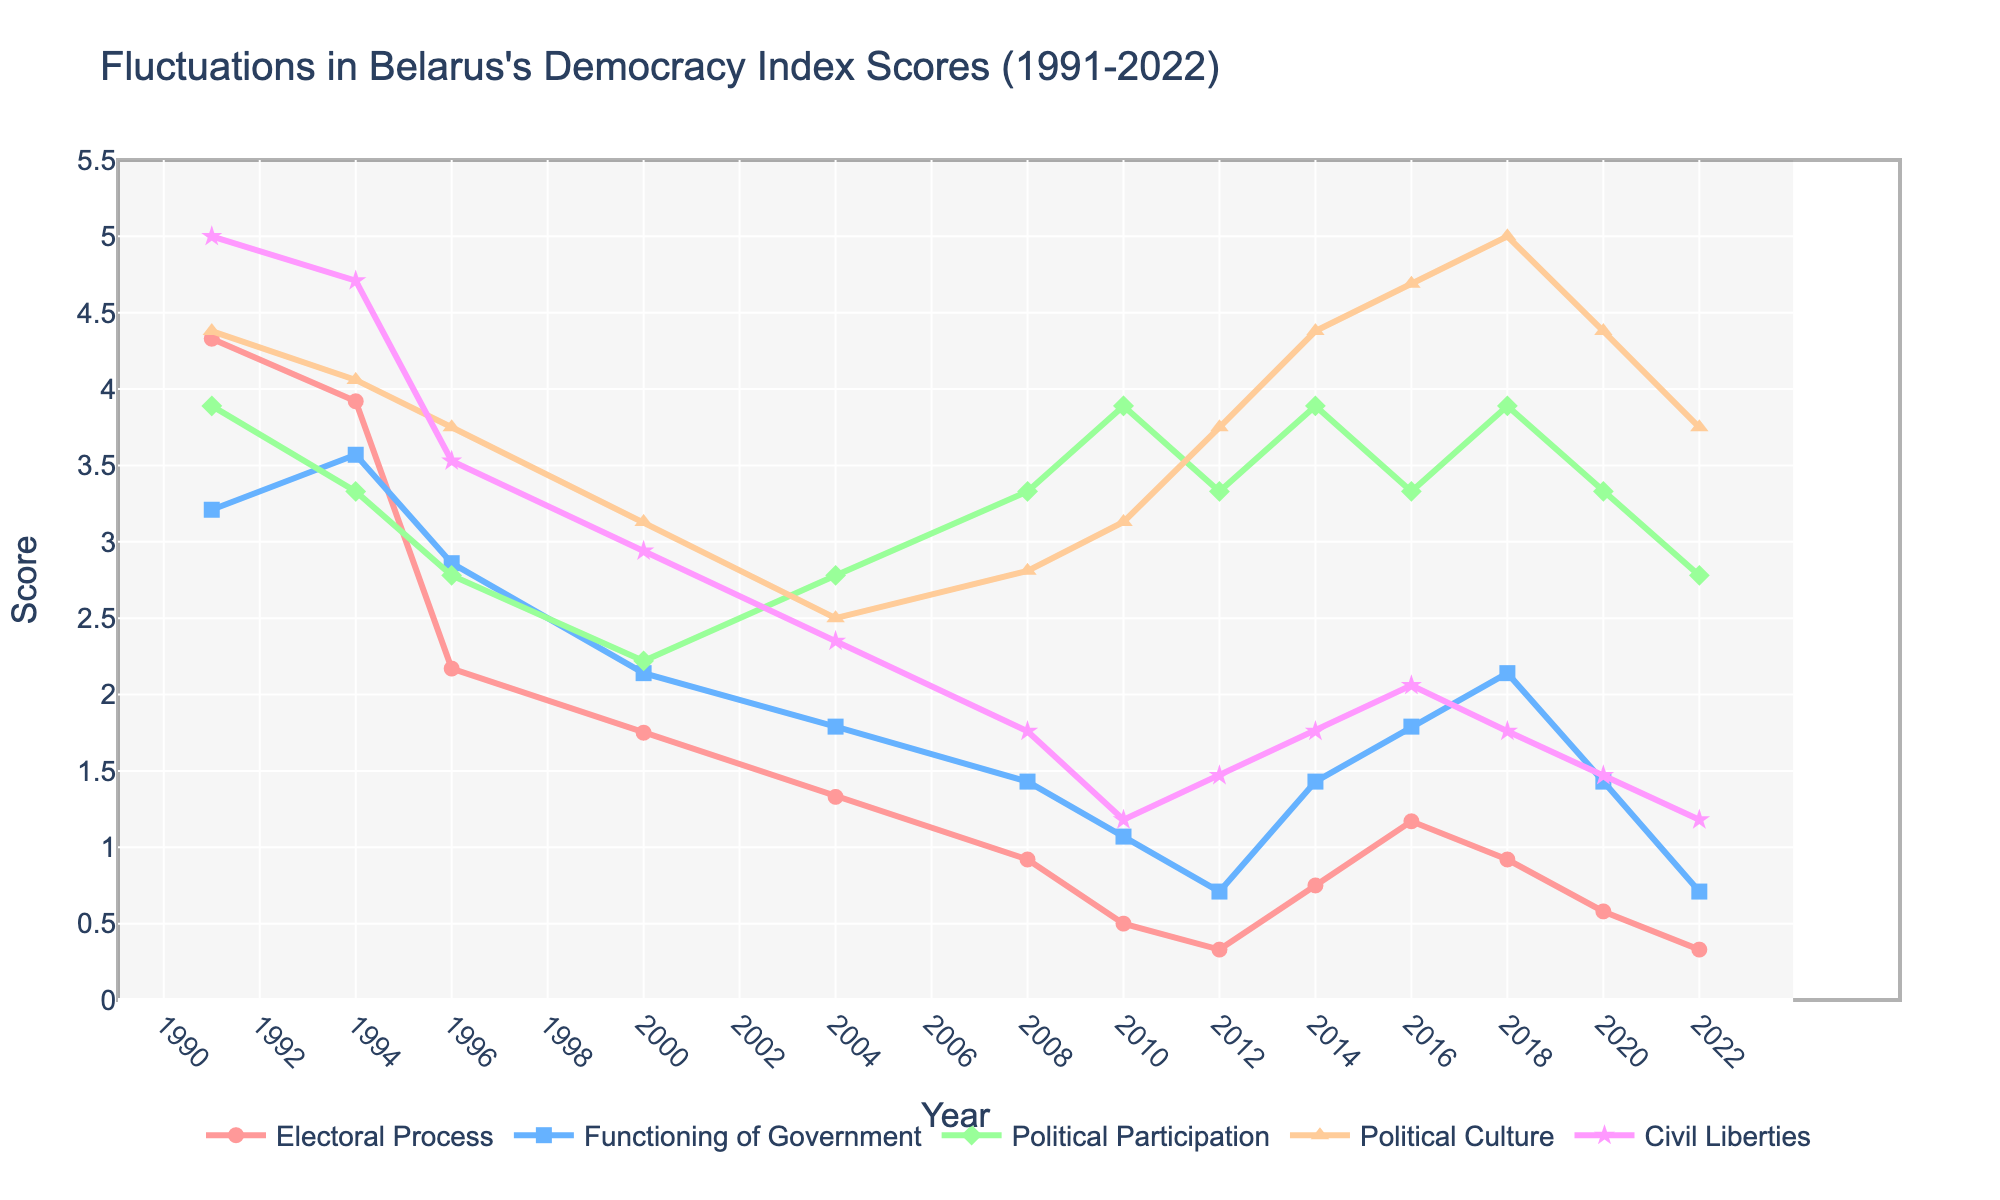What year had the highest score for Political Culture? Looking at the plot, find the highest point for the Political Culture line (triangle-up markers). The highest point is in the year 2018.
Answer: 2018 Which category showed the most drastic decline from 1991 to 1994? Compare the slopes of the lines from 1991 to 1994 for each category. The Electoral Process (red line with circle markers) showed the most significant drop.
Answer: Electoral Process How many categories scored below 2.0 in 2022? Check the y-values for each category in 2022 and count how many are below 2.0. There are three: Electoral Process, Functioning of Government, and Civil Liberties.
Answer: 3 In which year did Civil Liberties have its lowest score? Look at the plot and identify the lowest point on the Civil Liberties curve (star markers). The lowest point is in 2010.
Answer: 2010 What was the average score for the Functioning of Government in the years 2004, 2008, and 2012? Calculate the average by summing up the Functioning of Government scores for 2004, 2008, and 2012 then dividing by 3. \((1.79 + 1.43 + 0.71)/3 = 1.31\).
Answer: 1.31 Which category had the highest score in 1991? Look at the plot for 1991 and see which category has the highest y-value. Civil Liberties was at 5.0, which is the highest.
Answer: Civil Liberties Did Political Participation ever reach 4.0 or higher after 1991? Scan the plot for the Political Participation line (diamond markers) after 1991 for any point at or above 4.0. The peaks do not reach 4.0 or higher.
Answer: No Compare the scores of Electoral Process and Civil Liberties in 2020. Which was higher? Read off the plot values for 2020 for the Electoral Process and Civil Liberties. Electoral Process is 0.58, and Civil Liberties is 1.47. Civil Liberties is higher.
Answer: Civil Liberties Was there any year where all categories had scores below 4.0? Look through each year and check if all categories are below 4.0 for any year. In multiple years (e.g., 2000, 2004, 2008, 2010, 2012), all categories were below 4.0.
Answer: Yes 